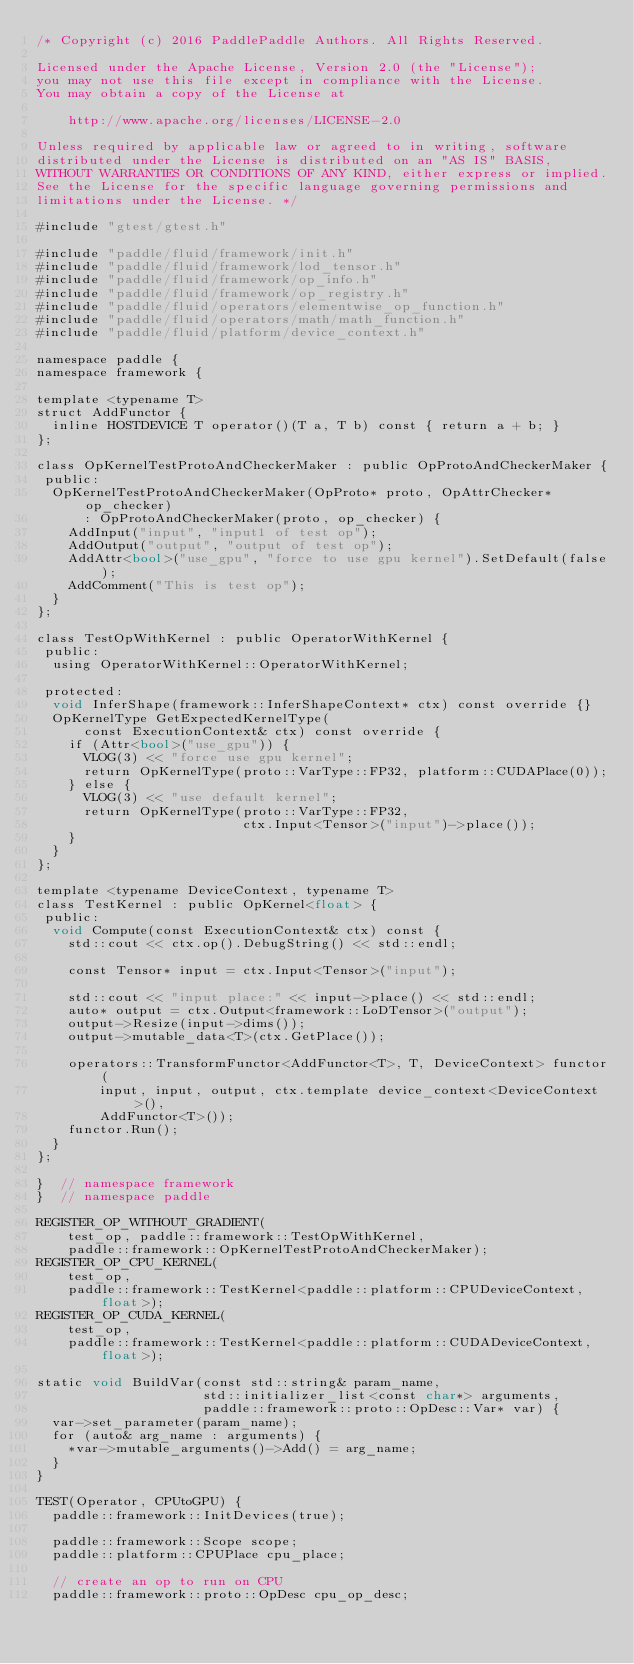Convert code to text. <code><loc_0><loc_0><loc_500><loc_500><_Cuda_>/* Copyright (c) 2016 PaddlePaddle Authors. All Rights Reserved.

Licensed under the Apache License, Version 2.0 (the "License");
you may not use this file except in compliance with the License.
You may obtain a copy of the License at

    http://www.apache.org/licenses/LICENSE-2.0

Unless required by applicable law or agreed to in writing, software
distributed under the License is distributed on an "AS IS" BASIS,
WITHOUT WARRANTIES OR CONDITIONS OF ANY KIND, either express or implied.
See the License for the specific language governing permissions and
limitations under the License. */

#include "gtest/gtest.h"

#include "paddle/fluid/framework/init.h"
#include "paddle/fluid/framework/lod_tensor.h"
#include "paddle/fluid/framework/op_info.h"
#include "paddle/fluid/framework/op_registry.h"
#include "paddle/fluid/operators/elementwise_op_function.h"
#include "paddle/fluid/operators/math/math_function.h"
#include "paddle/fluid/platform/device_context.h"

namespace paddle {
namespace framework {

template <typename T>
struct AddFunctor {
  inline HOSTDEVICE T operator()(T a, T b) const { return a + b; }
};

class OpKernelTestProtoAndCheckerMaker : public OpProtoAndCheckerMaker {
 public:
  OpKernelTestProtoAndCheckerMaker(OpProto* proto, OpAttrChecker* op_checker)
      : OpProtoAndCheckerMaker(proto, op_checker) {
    AddInput("input", "input1 of test op");
    AddOutput("output", "output of test op");
    AddAttr<bool>("use_gpu", "force to use gpu kernel").SetDefault(false);
    AddComment("This is test op");
  }
};

class TestOpWithKernel : public OperatorWithKernel {
 public:
  using OperatorWithKernel::OperatorWithKernel;

 protected:
  void InferShape(framework::InferShapeContext* ctx) const override {}
  OpKernelType GetExpectedKernelType(
      const ExecutionContext& ctx) const override {
    if (Attr<bool>("use_gpu")) {
      VLOG(3) << "force use gpu kernel";
      return OpKernelType(proto::VarType::FP32, platform::CUDAPlace(0));
    } else {
      VLOG(3) << "use default kernel";
      return OpKernelType(proto::VarType::FP32,
                          ctx.Input<Tensor>("input")->place());
    }
  }
};

template <typename DeviceContext, typename T>
class TestKernel : public OpKernel<float> {
 public:
  void Compute(const ExecutionContext& ctx) const {
    std::cout << ctx.op().DebugString() << std::endl;

    const Tensor* input = ctx.Input<Tensor>("input");

    std::cout << "input place:" << input->place() << std::endl;
    auto* output = ctx.Output<framework::LoDTensor>("output");
    output->Resize(input->dims());
    output->mutable_data<T>(ctx.GetPlace());

    operators::TransformFunctor<AddFunctor<T>, T, DeviceContext> functor(
        input, input, output, ctx.template device_context<DeviceContext>(),
        AddFunctor<T>());
    functor.Run();
  }
};

}  // namespace framework
}  // namespace paddle

REGISTER_OP_WITHOUT_GRADIENT(
    test_op, paddle::framework::TestOpWithKernel,
    paddle::framework::OpKernelTestProtoAndCheckerMaker);
REGISTER_OP_CPU_KERNEL(
    test_op,
    paddle::framework::TestKernel<paddle::platform::CPUDeviceContext, float>);
REGISTER_OP_CUDA_KERNEL(
    test_op,
    paddle::framework::TestKernel<paddle::platform::CUDADeviceContext, float>);

static void BuildVar(const std::string& param_name,
                     std::initializer_list<const char*> arguments,
                     paddle::framework::proto::OpDesc::Var* var) {
  var->set_parameter(param_name);
  for (auto& arg_name : arguments) {
    *var->mutable_arguments()->Add() = arg_name;
  }
}

TEST(Operator, CPUtoGPU) {
  paddle::framework::InitDevices(true);

  paddle::framework::Scope scope;
  paddle::platform::CPUPlace cpu_place;

  // create an op to run on CPU
  paddle::framework::proto::OpDesc cpu_op_desc;</code> 